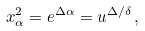Convert formula to latex. <formula><loc_0><loc_0><loc_500><loc_500>x _ { \alpha } ^ { 2 } = e ^ { \Delta \alpha } = u ^ { \Delta / \delta } \, ,</formula> 